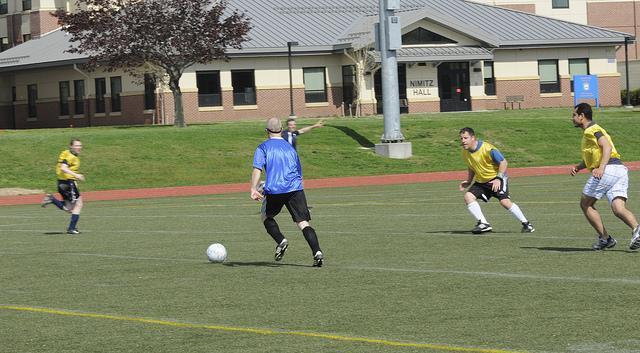How many people are in the picture?
Give a very brief answer. 3. 